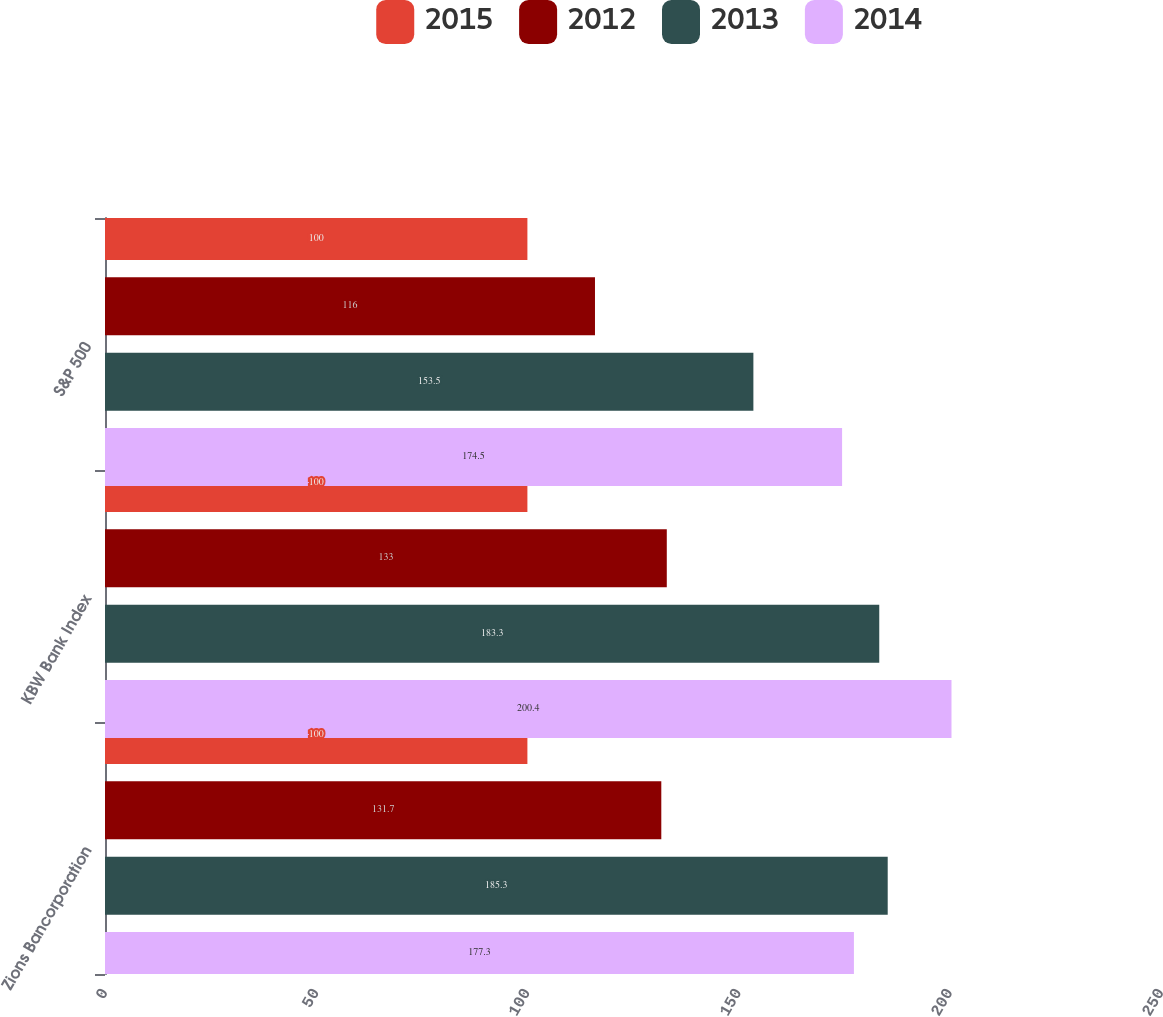<chart> <loc_0><loc_0><loc_500><loc_500><stacked_bar_chart><ecel><fcel>Zions Bancorporation<fcel>KBW Bank Index<fcel>S&P 500<nl><fcel>2015<fcel>100<fcel>100<fcel>100<nl><fcel>2012<fcel>131.7<fcel>133<fcel>116<nl><fcel>2013<fcel>185.3<fcel>183.3<fcel>153.5<nl><fcel>2014<fcel>177.3<fcel>200.4<fcel>174.5<nl></chart> 